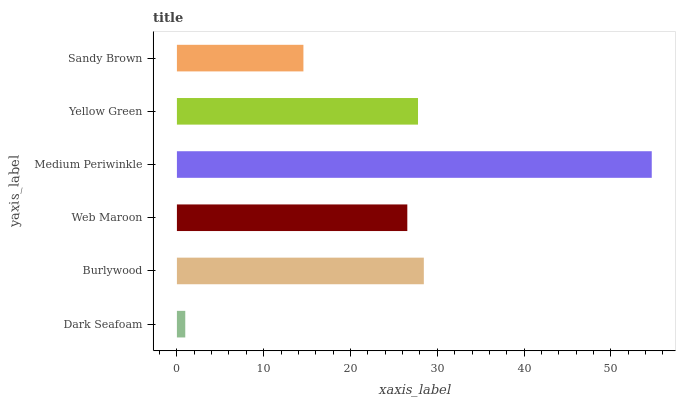Is Dark Seafoam the minimum?
Answer yes or no. Yes. Is Medium Periwinkle the maximum?
Answer yes or no. Yes. Is Burlywood the minimum?
Answer yes or no. No. Is Burlywood the maximum?
Answer yes or no. No. Is Burlywood greater than Dark Seafoam?
Answer yes or no. Yes. Is Dark Seafoam less than Burlywood?
Answer yes or no. Yes. Is Dark Seafoam greater than Burlywood?
Answer yes or no. No. Is Burlywood less than Dark Seafoam?
Answer yes or no. No. Is Yellow Green the high median?
Answer yes or no. Yes. Is Web Maroon the low median?
Answer yes or no. Yes. Is Web Maroon the high median?
Answer yes or no. No. Is Sandy Brown the low median?
Answer yes or no. No. 